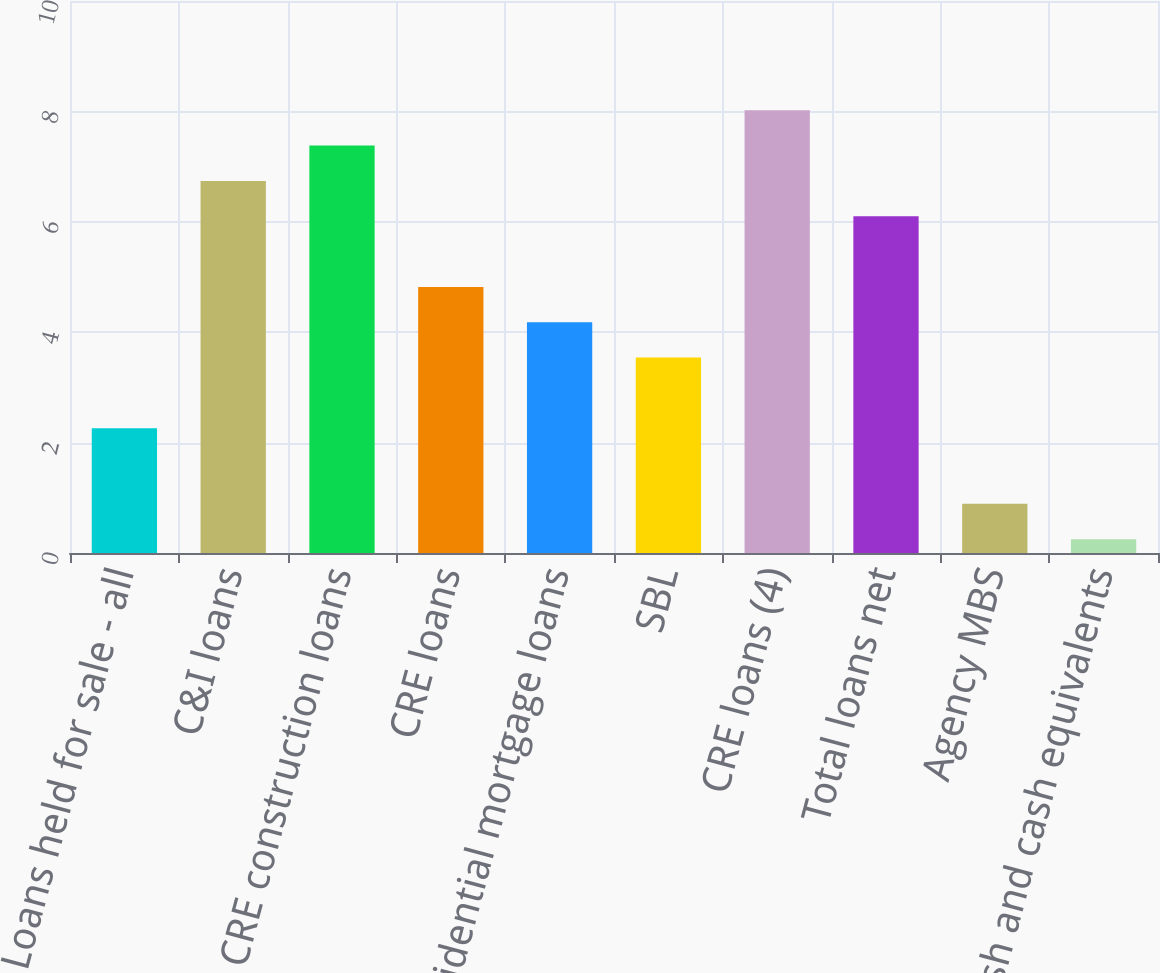Convert chart to OTSL. <chart><loc_0><loc_0><loc_500><loc_500><bar_chart><fcel>Loans held for sale - all<fcel>C&I loans<fcel>CRE construction loans<fcel>CRE loans<fcel>Residential mortgage loans<fcel>SBL<fcel>CRE loans (4)<fcel>Total loans net<fcel>Agency MBS<fcel>Cash and cash equivalents<nl><fcel>2.26<fcel>6.74<fcel>7.38<fcel>4.82<fcel>4.18<fcel>3.54<fcel>8.02<fcel>6.1<fcel>0.89<fcel>0.25<nl></chart> 